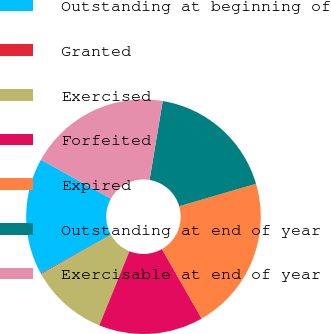Convert chart. <chart><loc_0><loc_0><loc_500><loc_500><pie_chart><fcel>Outstanding at beginning of<fcel>Granted<fcel>Exercised<fcel>Forfeited<fcel>Expired<fcel>Outstanding at end of year<fcel>Exercisable at end of year<nl><fcel>16.12%<fcel>0.11%<fcel>10.7%<fcel>14.41%<fcel>21.27%<fcel>17.84%<fcel>19.55%<nl></chart> 